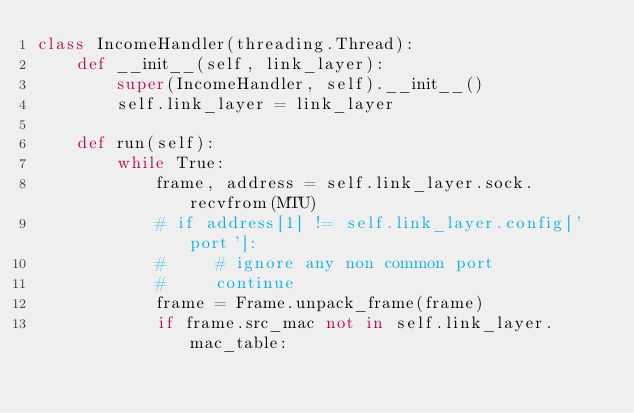Convert code to text. <code><loc_0><loc_0><loc_500><loc_500><_Python_>class IncomeHandler(threading.Thread):
    def __init__(self, link_layer):
        super(IncomeHandler, self).__init__()
        self.link_layer = link_layer

    def run(self):
        while True:
            frame, address = self.link_layer.sock.recvfrom(MTU)
            # if address[1] != self.link_layer.config['port']:
            #     # ignore any non common port
            #     continue
            frame = Frame.unpack_frame(frame)
            if frame.src_mac not in self.link_layer.mac_table:</code> 